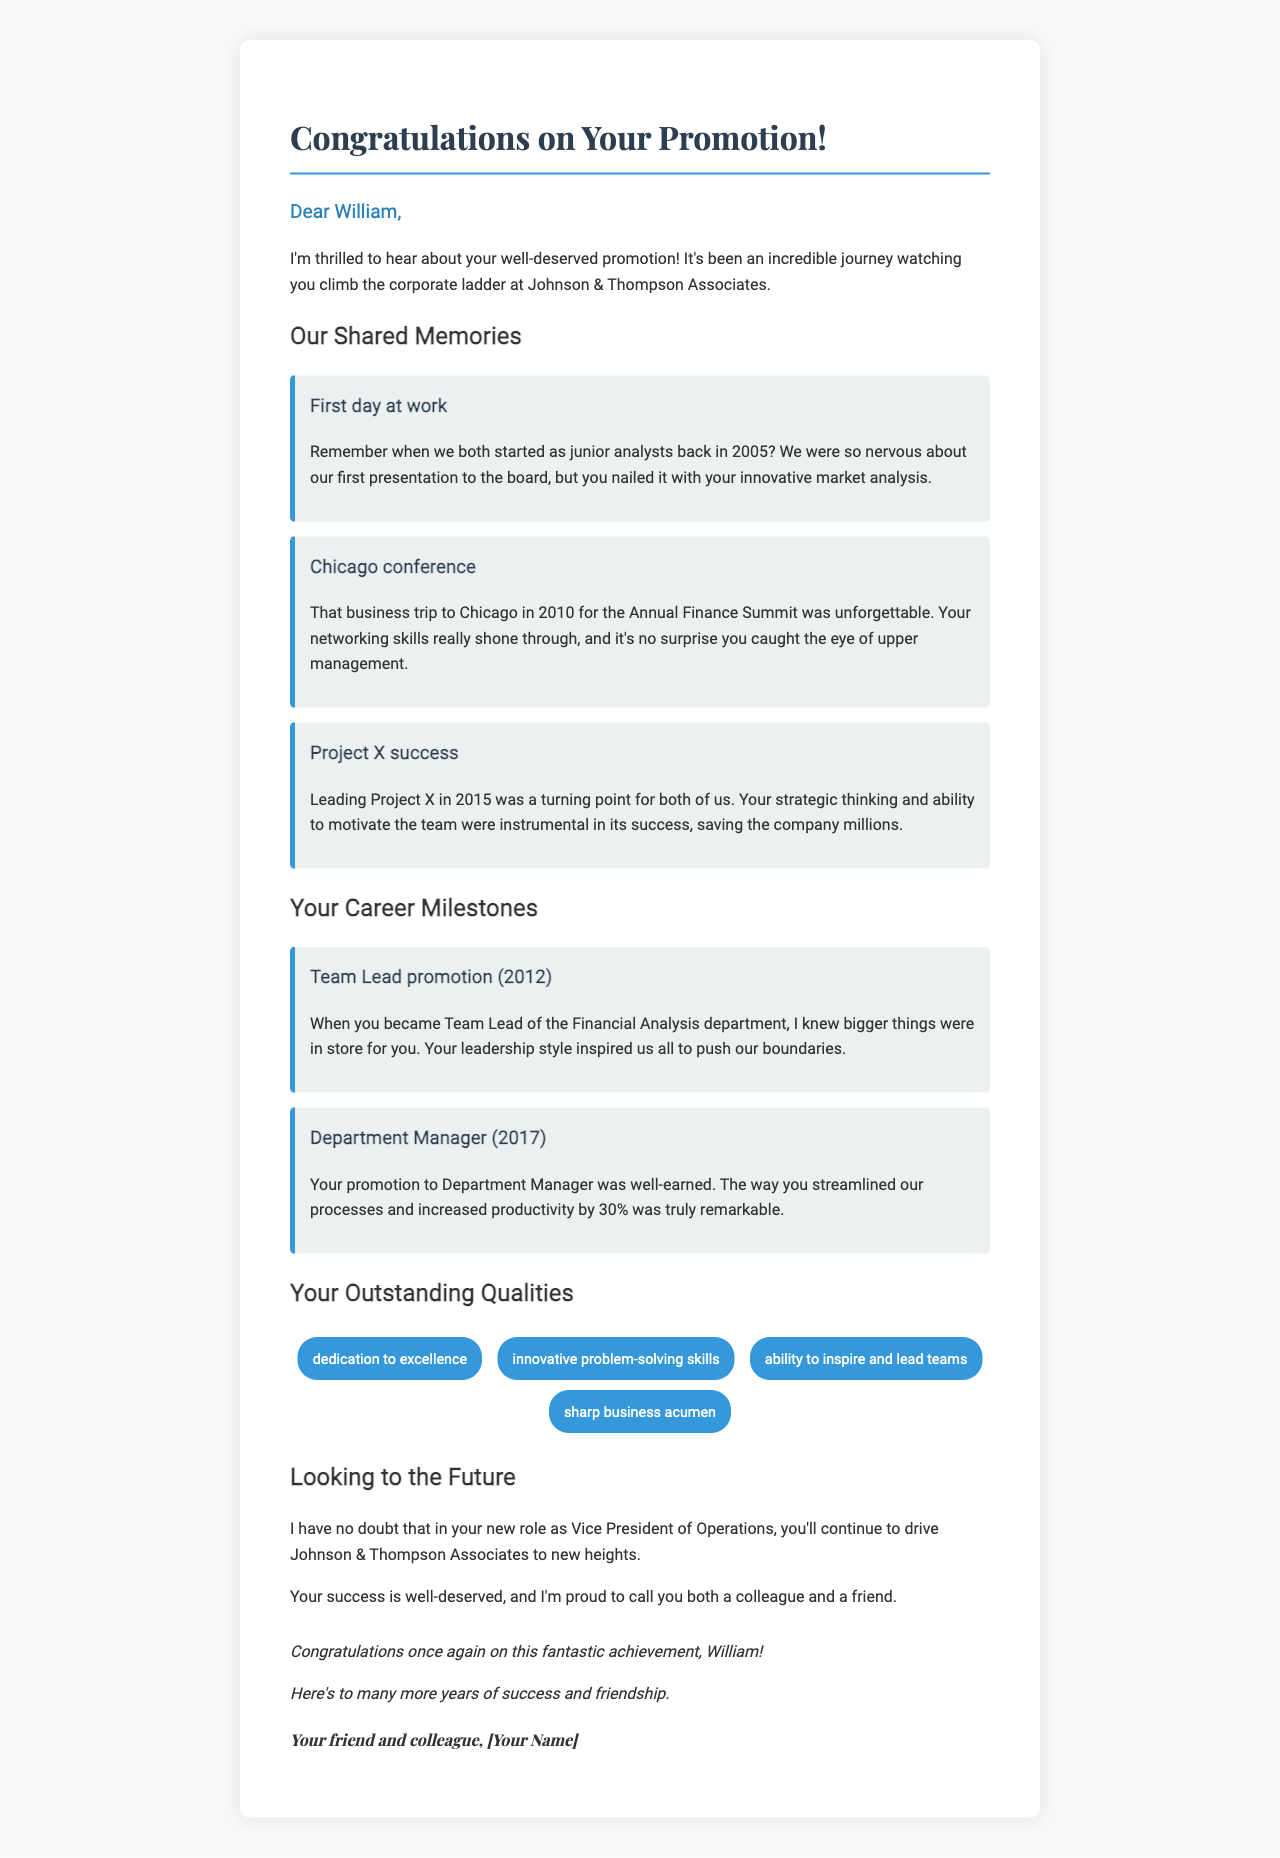What year did William start as a junior analyst? It was in 2005 when William started as a junior analyst.
Answer: 2005 What position did William hold in 2012? In 2012, William became the Team Lead of the Financial Analysis department.
Answer: Team Lead What was the main contribution of William during Project X in 2015? William's strategic thinking and ability to motivate the team were instrumental in the success of Project X.
Answer: Strategic thinking How much did William increase productivity as a Department Manager? William increased productivity by 30% when he became Department Manager.
Answer: 30% What event is noted for highlighting William's networking skills? The Chicago conference in 2010 is where William's networking skills shone through.
Answer: Chicago conference What title has William recently earned? William has recently been promoted to Vice President of Operations.
Answer: Vice President of Operations What personal quality is associated with William's success? His dedication to excellence is a key personal quality associated with his success.
Answer: Dedication to excellence What is the overall tone of the letter? The letter conveys a heartfelt and congratulatory tone towards William's achievement.
Answer: Heartfelt What is the subject of the letter? The subject of the letter is William's promotion.
Answer: Promotion 